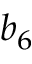Convert formula to latex. <formula><loc_0><loc_0><loc_500><loc_500>b _ { 6 }</formula> 